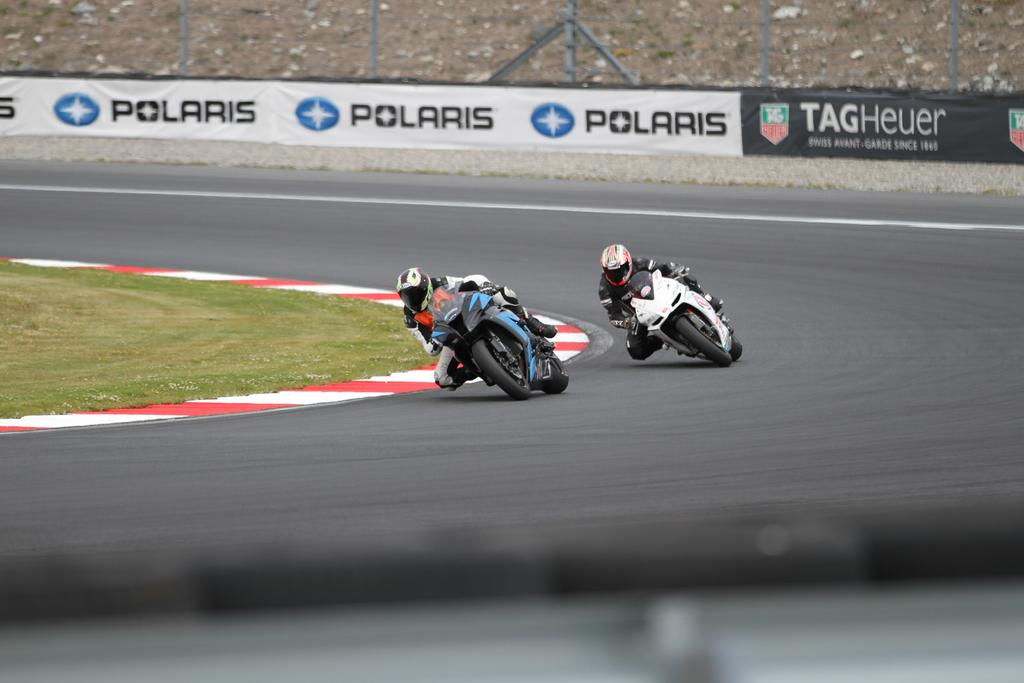What is the main feature of the image? There is a road in the image. What can be seen on the road? There are two bikes on the road. Who is riding the bikes? Two people are riding the bikes. What is visible in the background of the image? There is a banner visible in the background of the image. Where is the bat located in the image? There is no bat present in the image. What type of bucket can be seen in the image? There is no bucket present in the image. 